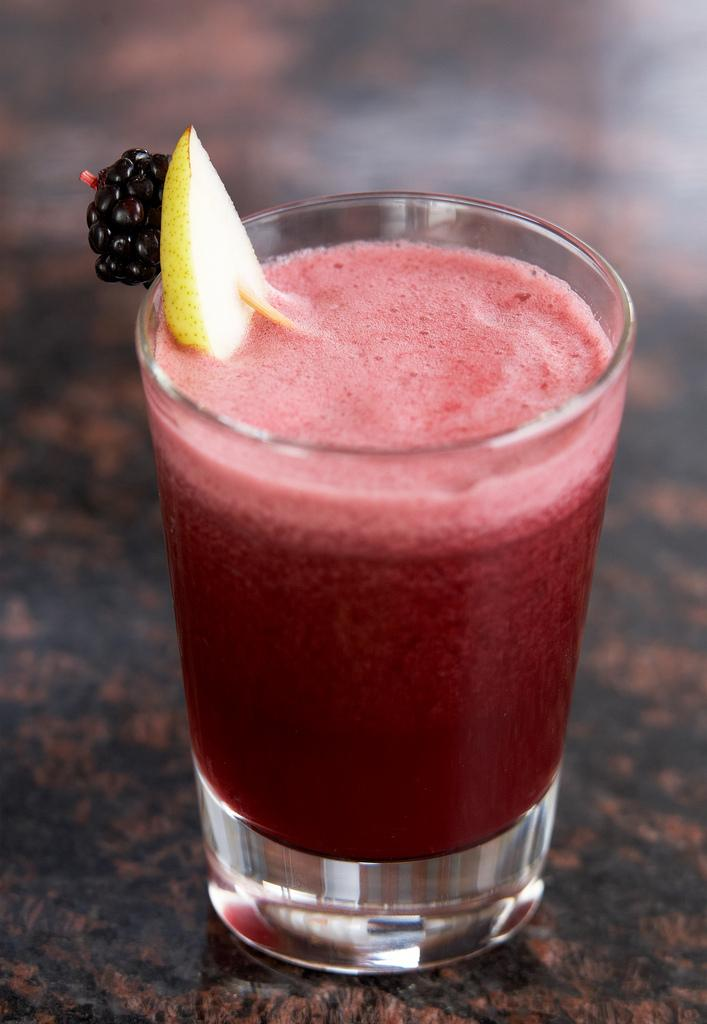What type of beverage is in the picture? There is a juice in the picture. What color is the juice? The juice is in red color. How is the juice being served? The juice is presented in a glass. What fruits are in the glass with the juice? There is an apple and a berry in the glass with the juice. What is the most efficient route to take to avoid the pest in the image? There is no pest present in the image, so there is no need to avoid it or plan a route. 